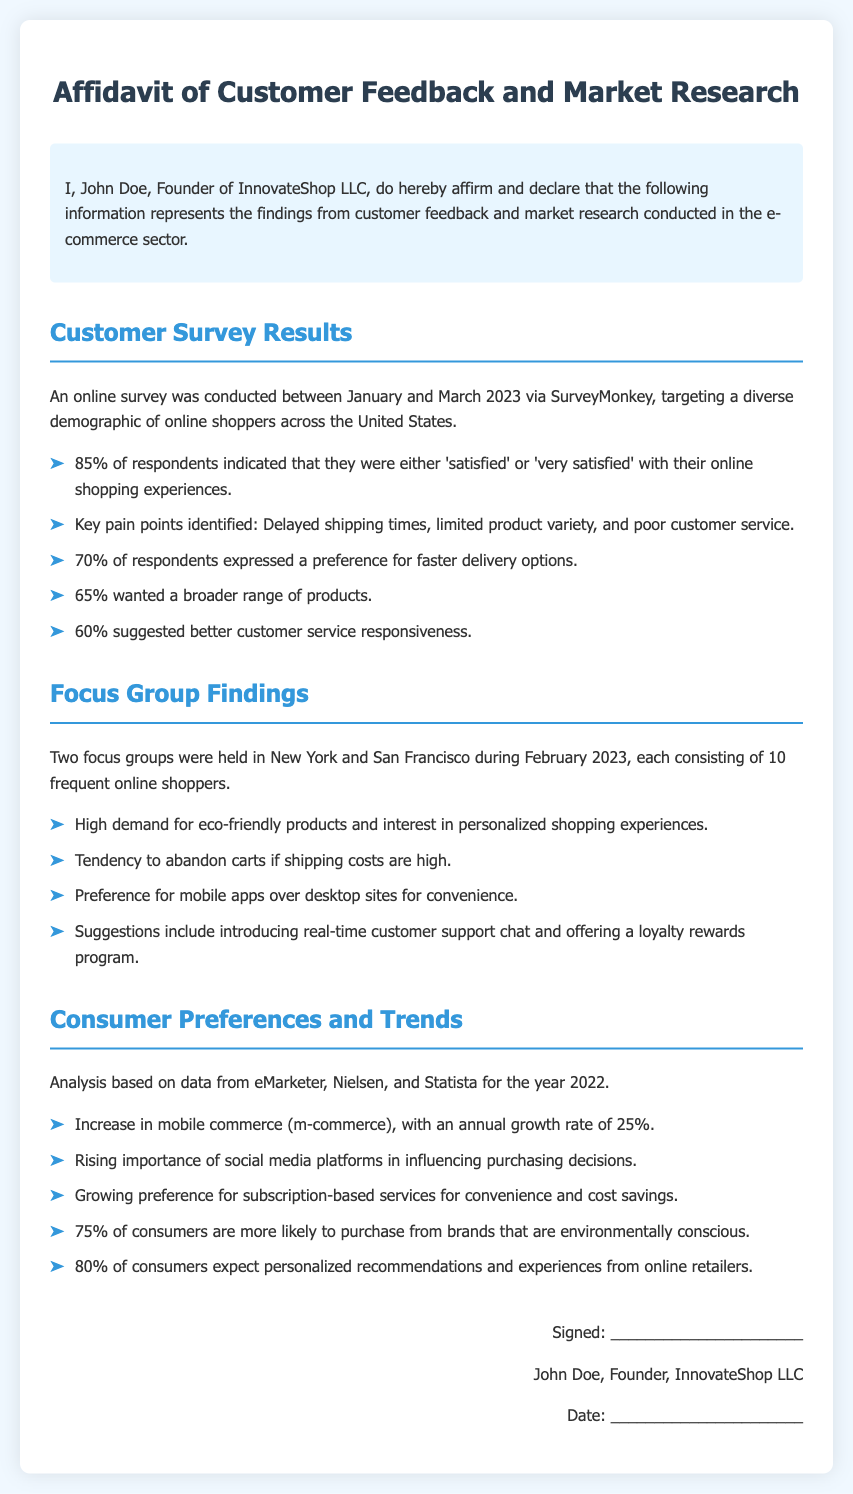What percentage of respondents were satisfied with their online shopping experiences? 85% of respondents indicated satisfaction levels with their experiences as 'satisfied' or 'very satisfied'.
Answer: 85% What are the key pain points identified by customers? The document lists delayed shipping times, limited product variety, and poor customer service as key pain points.
Answer: Delayed shipping times, limited product variety, and poor customer service What preference did 70% of respondents express? 70% of respondents expressed a preference for faster delivery options, indicating a demand for improved shipping times.
Answer: Faster delivery options How many focus groups were conducted, and where? Two focus groups were held, one in New York and the other in San Francisco, which involved frequent online shoppers.
Answer: Two, New York and San Francisco What is the annual growth rate of mobile commerce? The analysis reveals an annual growth rate of 25% for mobile commerce in 2022.
Answer: 25% What percentage of consumers expect personalized recommendations? 80% of consumers expect personalized recommendations and experiences from online retailers based on the trends discussed.
Answer: 80% What is a suggested feature for improving customer support? The document suggests introducing real-time customer support chat as a way to enhance customer support services.
Answer: Real-time customer support chat What percentage of consumers are likely to purchase from environmentally conscious brands? The findings indicate that 75% of consumers are more likely to purchase from brands that are environmentally conscious.
Answer: 75% 